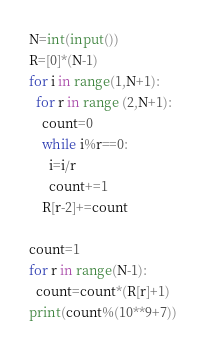<code> <loc_0><loc_0><loc_500><loc_500><_Python_>N=int(input())
R=[0]*(N-1)
for i in range(1,N+1):
  for r in range (2,N+1):
    count=0
    while i%r==0:
      i=i/r
      count+=1
    R[r-2]+=count

count=1
for r in range(N-1):
  count=count*(R[r]+1)
print(count%(10**9+7))</code> 